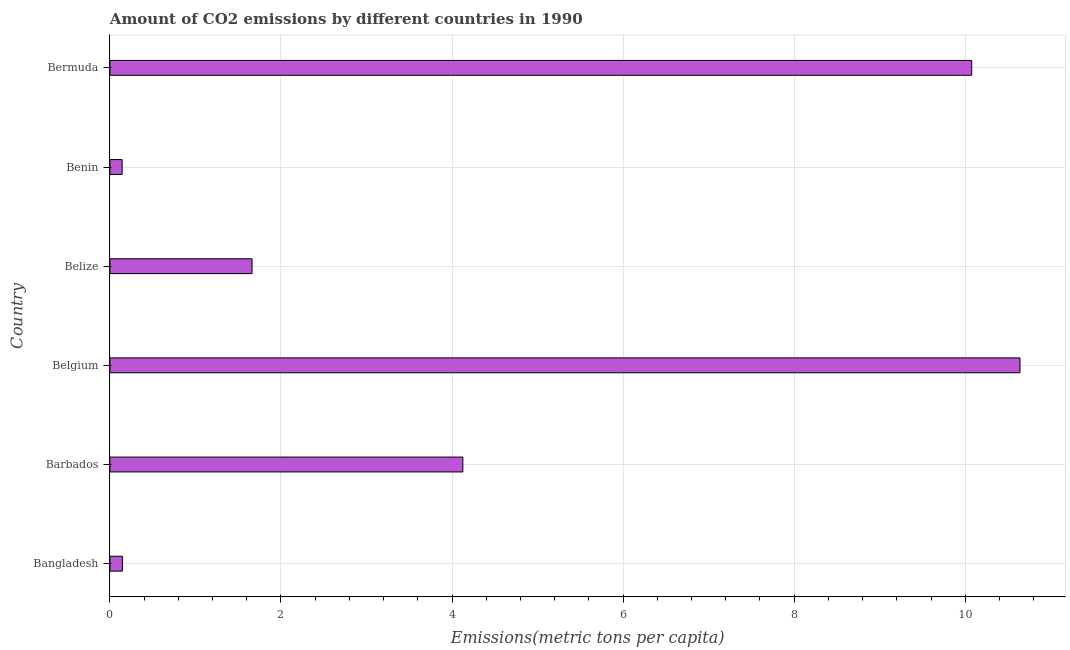Does the graph contain grids?
Provide a short and direct response. Yes. What is the title of the graph?
Your answer should be compact. Amount of CO2 emissions by different countries in 1990. What is the label or title of the X-axis?
Offer a terse response. Emissions(metric tons per capita). What is the label or title of the Y-axis?
Offer a very short reply. Country. What is the amount of co2 emissions in Benin?
Make the answer very short. 0.14. Across all countries, what is the maximum amount of co2 emissions?
Your response must be concise. 10.64. Across all countries, what is the minimum amount of co2 emissions?
Your answer should be very brief. 0.14. In which country was the amount of co2 emissions minimum?
Give a very brief answer. Benin. What is the sum of the amount of co2 emissions?
Provide a succinct answer. 26.79. What is the difference between the amount of co2 emissions in Bangladesh and Benin?
Your answer should be compact. 0. What is the average amount of co2 emissions per country?
Your answer should be very brief. 4.46. What is the median amount of co2 emissions?
Provide a short and direct response. 2.89. What is the ratio of the amount of co2 emissions in Barbados to that in Benin?
Your response must be concise. 28.86. Is the difference between the amount of co2 emissions in Bangladesh and Belgium greater than the difference between any two countries?
Your answer should be very brief. No. What is the difference between the highest and the second highest amount of co2 emissions?
Make the answer very short. 0.56. Is the sum of the amount of co2 emissions in Bangladesh and Belize greater than the maximum amount of co2 emissions across all countries?
Make the answer very short. No. How many countries are there in the graph?
Ensure brevity in your answer.  6. What is the difference between two consecutive major ticks on the X-axis?
Make the answer very short. 2. What is the Emissions(metric tons per capita) in Bangladesh?
Offer a terse response. 0.15. What is the Emissions(metric tons per capita) of Barbados?
Make the answer very short. 4.13. What is the Emissions(metric tons per capita) of Belgium?
Your response must be concise. 10.64. What is the Emissions(metric tons per capita) of Belize?
Give a very brief answer. 1.66. What is the Emissions(metric tons per capita) in Benin?
Offer a very short reply. 0.14. What is the Emissions(metric tons per capita) of Bermuda?
Your answer should be compact. 10.08. What is the difference between the Emissions(metric tons per capita) in Bangladesh and Barbados?
Offer a terse response. -3.98. What is the difference between the Emissions(metric tons per capita) in Bangladesh and Belgium?
Make the answer very short. -10.49. What is the difference between the Emissions(metric tons per capita) in Bangladesh and Belize?
Give a very brief answer. -1.52. What is the difference between the Emissions(metric tons per capita) in Bangladesh and Benin?
Provide a succinct answer. 0. What is the difference between the Emissions(metric tons per capita) in Bangladesh and Bermuda?
Make the answer very short. -9.93. What is the difference between the Emissions(metric tons per capita) in Barbados and Belgium?
Your answer should be very brief. -6.51. What is the difference between the Emissions(metric tons per capita) in Barbados and Belize?
Your answer should be very brief. 2.46. What is the difference between the Emissions(metric tons per capita) in Barbados and Benin?
Offer a terse response. 3.98. What is the difference between the Emissions(metric tons per capita) in Barbados and Bermuda?
Ensure brevity in your answer.  -5.95. What is the difference between the Emissions(metric tons per capita) in Belgium and Belize?
Keep it short and to the point. 8.98. What is the difference between the Emissions(metric tons per capita) in Belgium and Benin?
Give a very brief answer. 10.5. What is the difference between the Emissions(metric tons per capita) in Belgium and Bermuda?
Keep it short and to the point. 0.56. What is the difference between the Emissions(metric tons per capita) in Belize and Benin?
Your answer should be very brief. 1.52. What is the difference between the Emissions(metric tons per capita) in Belize and Bermuda?
Make the answer very short. -8.41. What is the difference between the Emissions(metric tons per capita) in Benin and Bermuda?
Ensure brevity in your answer.  -9.93. What is the ratio of the Emissions(metric tons per capita) in Bangladesh to that in Barbados?
Provide a short and direct response. 0.04. What is the ratio of the Emissions(metric tons per capita) in Bangladesh to that in Belgium?
Provide a short and direct response. 0.01. What is the ratio of the Emissions(metric tons per capita) in Bangladesh to that in Belize?
Make the answer very short. 0.09. What is the ratio of the Emissions(metric tons per capita) in Bangladesh to that in Benin?
Make the answer very short. 1.02. What is the ratio of the Emissions(metric tons per capita) in Bangladesh to that in Bermuda?
Offer a terse response. 0.01. What is the ratio of the Emissions(metric tons per capita) in Barbados to that in Belgium?
Offer a very short reply. 0.39. What is the ratio of the Emissions(metric tons per capita) in Barbados to that in Belize?
Give a very brief answer. 2.48. What is the ratio of the Emissions(metric tons per capita) in Barbados to that in Benin?
Your response must be concise. 28.86. What is the ratio of the Emissions(metric tons per capita) in Barbados to that in Bermuda?
Offer a very short reply. 0.41. What is the ratio of the Emissions(metric tons per capita) in Belgium to that in Belize?
Provide a succinct answer. 6.4. What is the ratio of the Emissions(metric tons per capita) in Belgium to that in Benin?
Your answer should be compact. 74.42. What is the ratio of the Emissions(metric tons per capita) in Belgium to that in Bermuda?
Make the answer very short. 1.06. What is the ratio of the Emissions(metric tons per capita) in Belize to that in Benin?
Give a very brief answer. 11.62. What is the ratio of the Emissions(metric tons per capita) in Belize to that in Bermuda?
Provide a succinct answer. 0.17. What is the ratio of the Emissions(metric tons per capita) in Benin to that in Bermuda?
Make the answer very short. 0.01. 